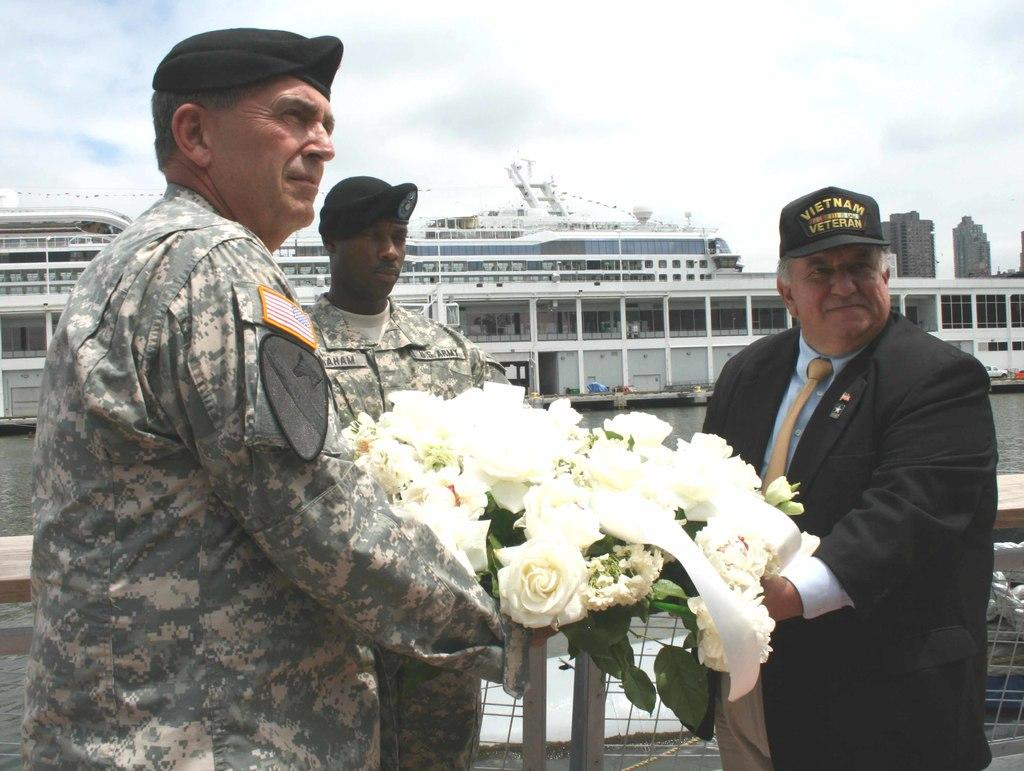What is the man in the image wearing? The man in the image is wearing a black dress. What is the man in the black dress doing in the image? The man in the black dress is giving flowers to an officer. Can you describe the officer in the image? There is an officer in the image who is receiving flowers from the man in the black dress. Are there any other people in the image besides the man in the black dress and the officer? Yes, there is another man standing nearby in the image. What can be seen in the background of the image? There is a big ship in the water in the image. What type of toy can be seen on the door in the image? There is no door or toy present in the image. 